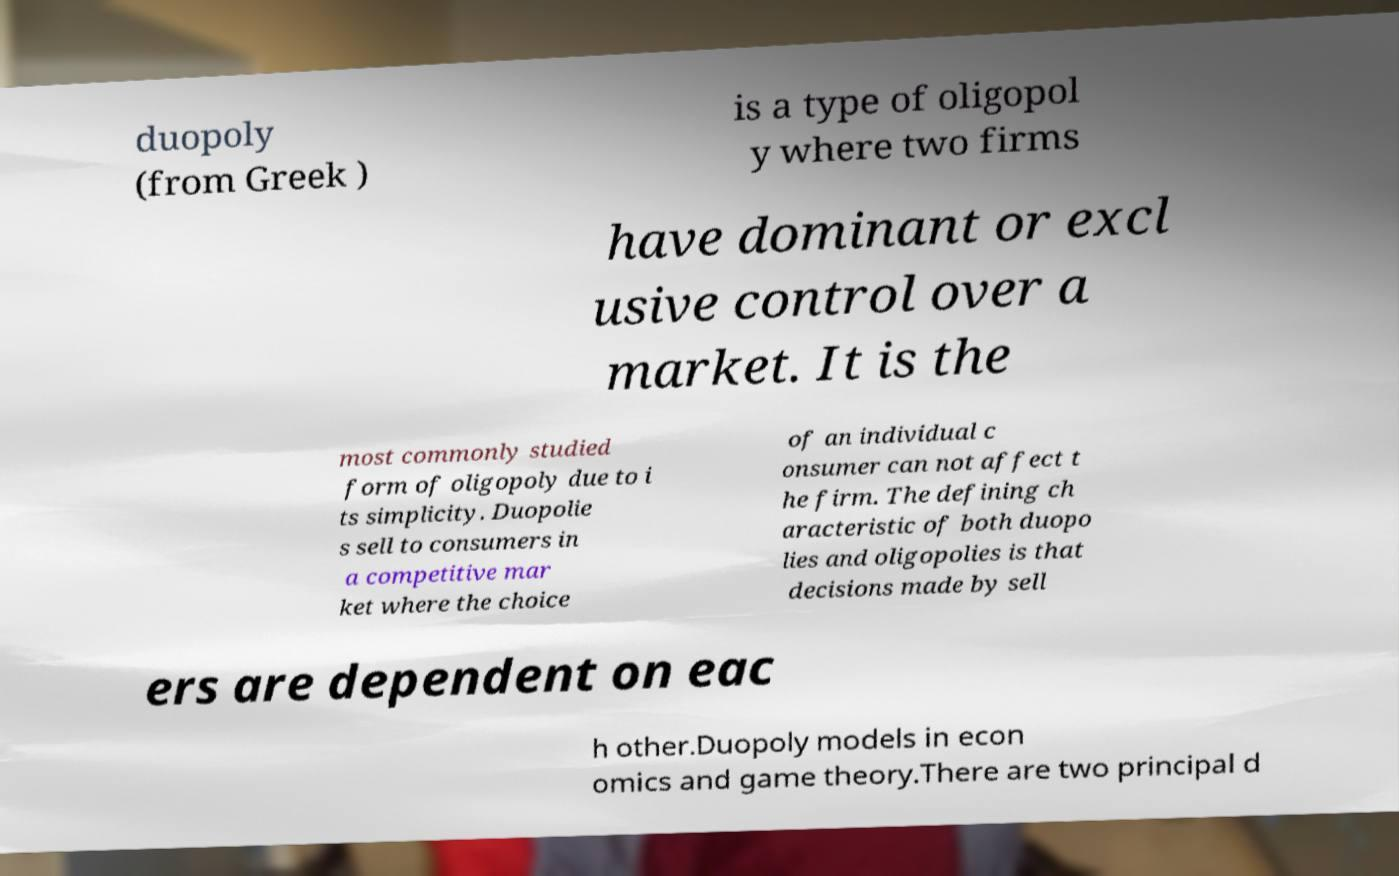For documentation purposes, I need the text within this image transcribed. Could you provide that? duopoly (from Greek ) is a type of oligopol y where two firms have dominant or excl usive control over a market. It is the most commonly studied form of oligopoly due to i ts simplicity. Duopolie s sell to consumers in a competitive mar ket where the choice of an individual c onsumer can not affect t he firm. The defining ch aracteristic of both duopo lies and oligopolies is that decisions made by sell ers are dependent on eac h other.Duopoly models in econ omics and game theory.There are two principal d 